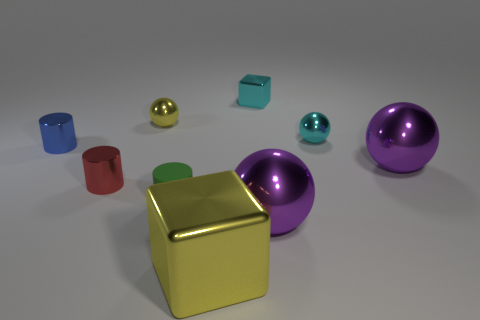What is the shape of the matte object?
Ensure brevity in your answer.  Cylinder. What number of red objects are made of the same material as the cyan cube?
Your answer should be compact. 1. There is a tiny block that is made of the same material as the large yellow object; what is its color?
Keep it short and to the point. Cyan. Do the purple metal thing that is behind the red metallic cylinder and the tiny green rubber thing have the same size?
Provide a short and direct response. No. What is the color of the other metallic object that is the same shape as the small blue thing?
Provide a succinct answer. Red. There is a big metal thing that is to the left of the small cyan shiny block that is on the right side of the small metal sphere to the left of the yellow block; what is its shape?
Provide a succinct answer. Cube. Is the tiny green rubber thing the same shape as the large yellow object?
Keep it short and to the point. No. There is a tiny cyan shiny thing on the left side of the purple metal sphere in front of the green object; what shape is it?
Offer a very short reply. Cube. Are any big blue shiny spheres visible?
Offer a terse response. No. How many metallic blocks are behind the tiny shiny sphere on the left side of the metallic cube right of the big yellow metallic block?
Make the answer very short. 1. 